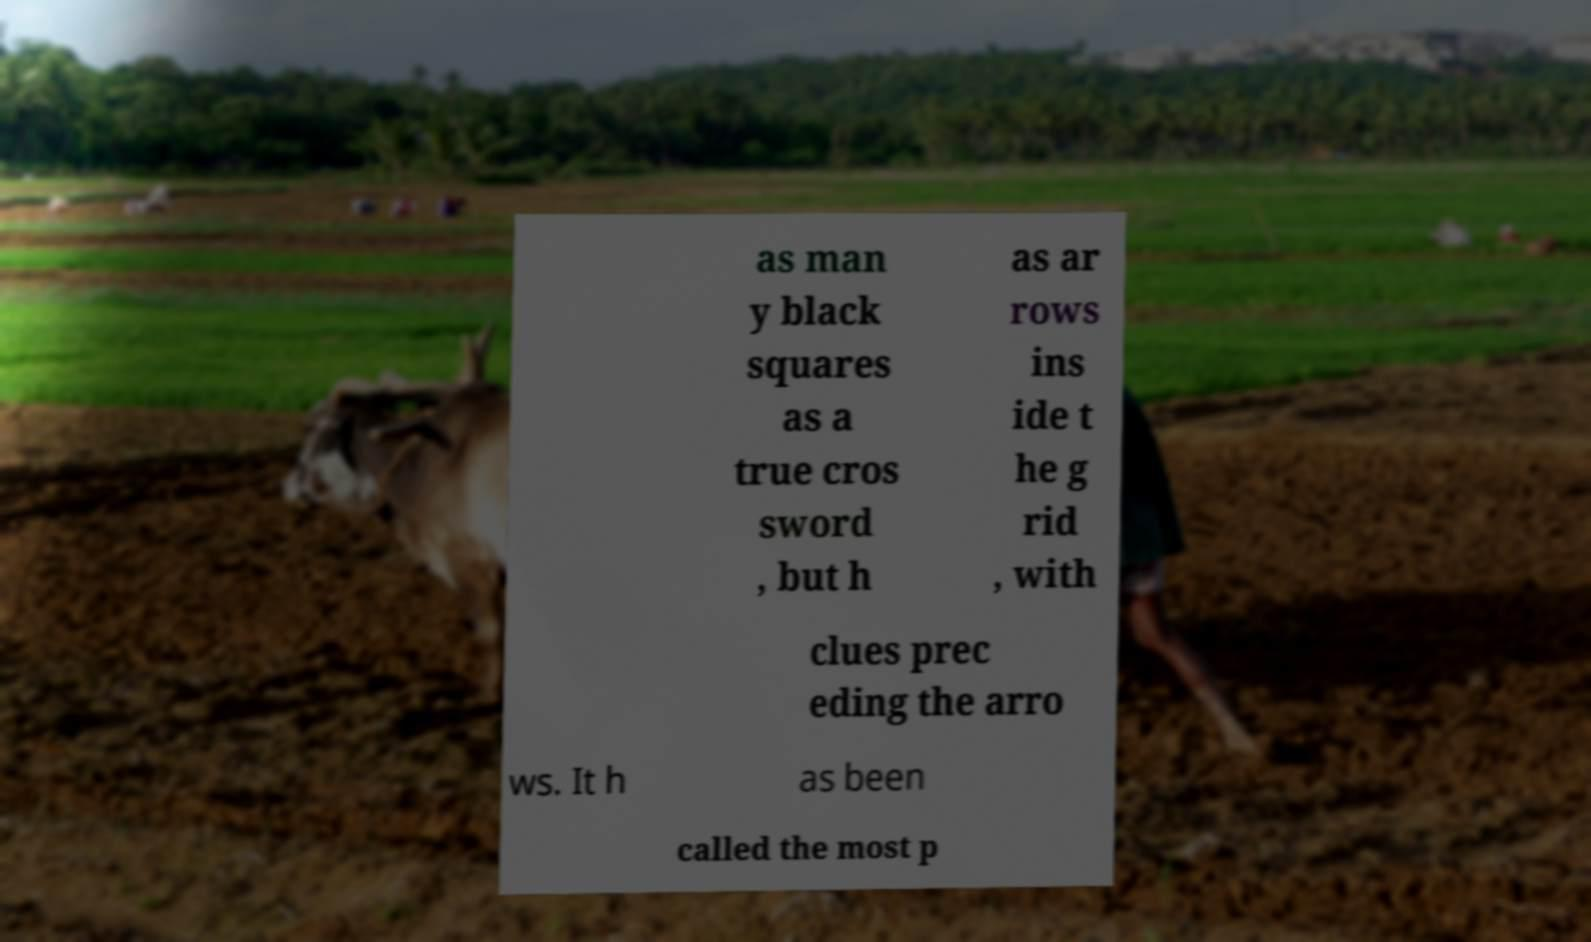Can you accurately transcribe the text from the provided image for me? as man y black squares as a true cros sword , but h as ar rows ins ide t he g rid , with clues prec eding the arro ws. It h as been called the most p 